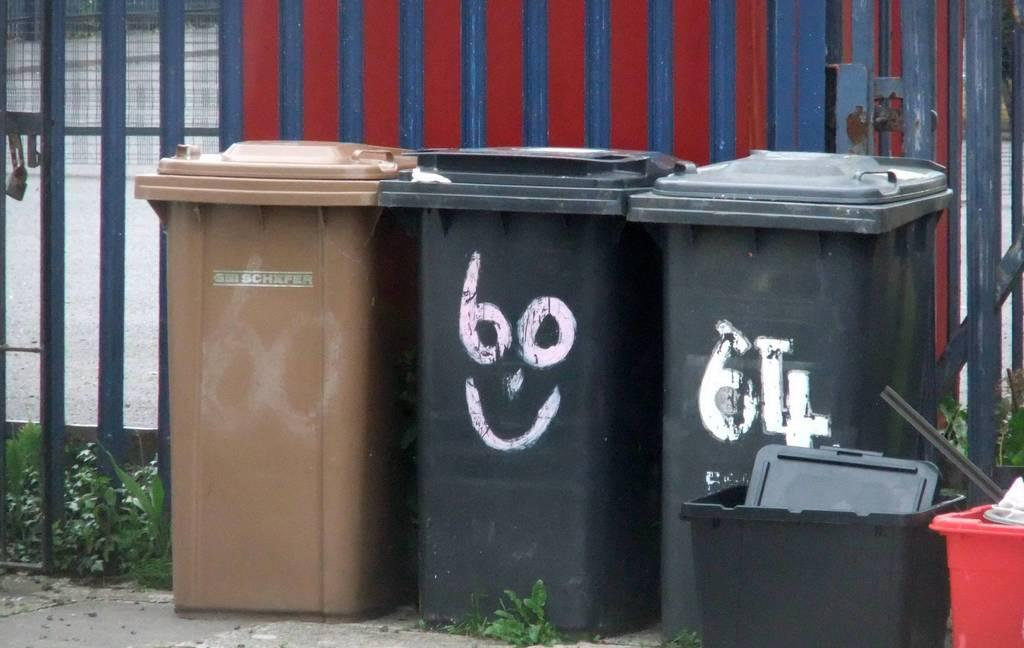<image>
Create a compact narrative representing the image presented. Garbage cans next to one another with one saying BO 